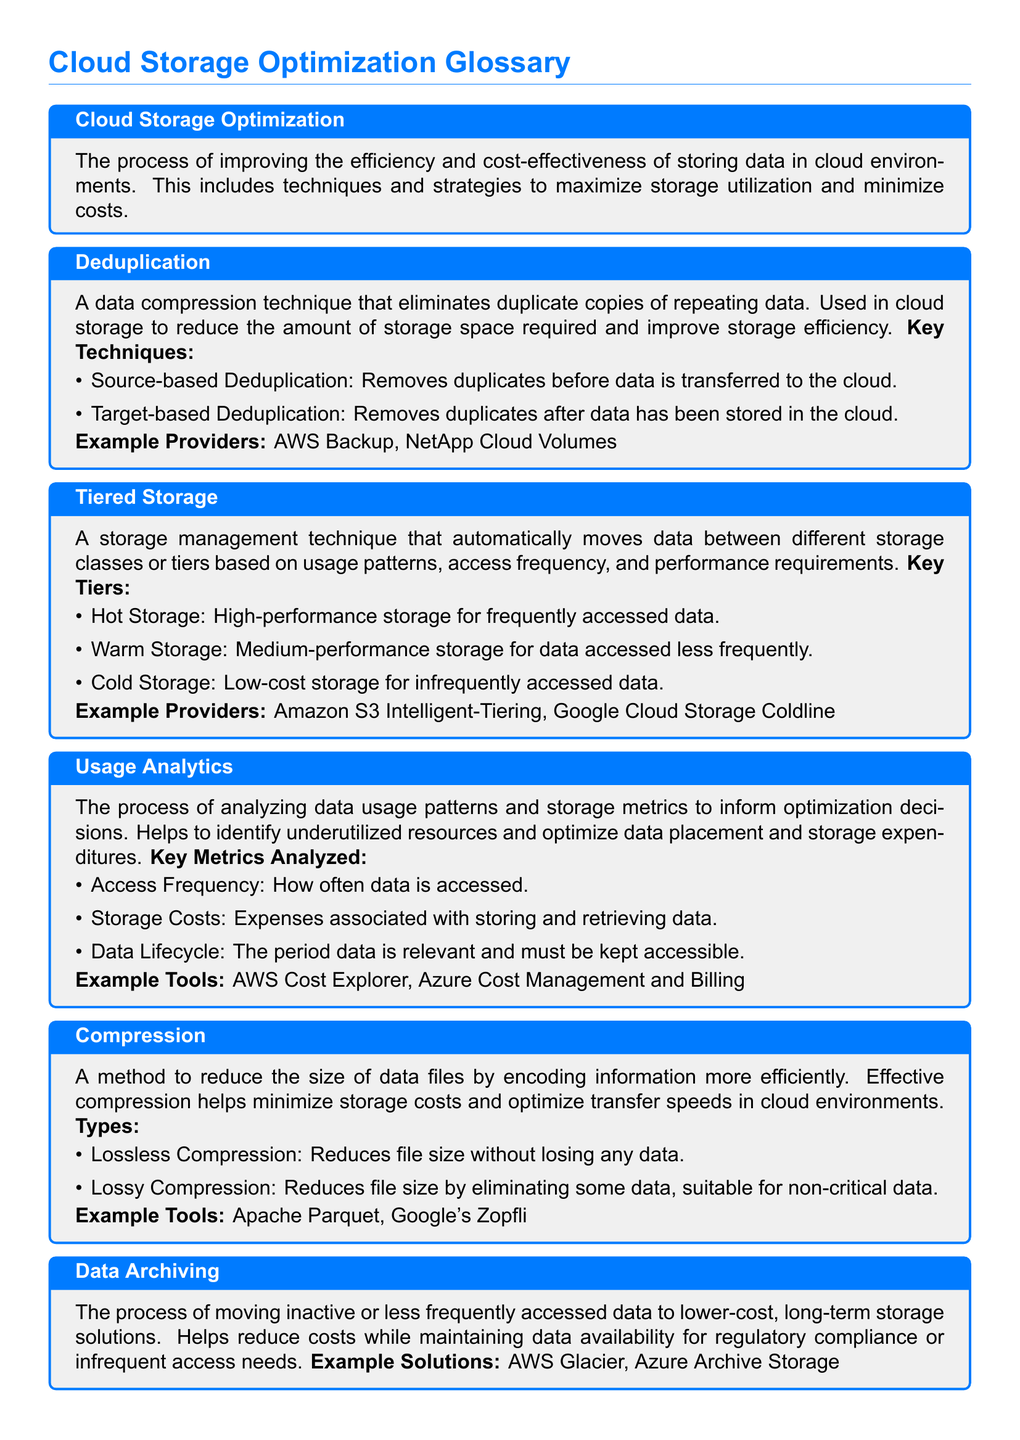What is cloud storage optimization? Cloud storage optimization refers to the process of improving the efficiency and cost-effectiveness of storing data in cloud environments.
Answer: The process of improving the efficiency and cost-effectiveness of storing data in cloud environments What does deduplication do? Deduplication removes duplicate copies of repeating data, thus reducing the amount of storage space required.
Answer: Eliminates duplicate copies of repeating data What are the three key storage tiers? The document lists three storage tiers for tiered storage management: hot, warm, and cold storage.
Answer: Hot, Warm, Cold What is usage analytics primarily used for? Usage analytics is utilized to inform optimization decisions by analyzing data usage patterns and storage metrics.
Answer: To inform optimization decisions What type of compression retains all data? The document mentions that lossless compression reduces file size without losing any data.
Answer: Lossless Compression Which provider offers cold storage solutions? AWS Glacier is provided as an example of a solution for data archiving in cold storage.
Answer: AWS Glacier Which key metric tracks how often data is accessed? Access frequency is defined as a key metric that tracks how often data is accessed.
Answer: Access Frequency What is the objective of data archiving? The objective of data archiving is to reduce costs while maintaining data availability for regulatory compliance or infrequent access needs.
Answer: Reduce costs while maintaining data availability 